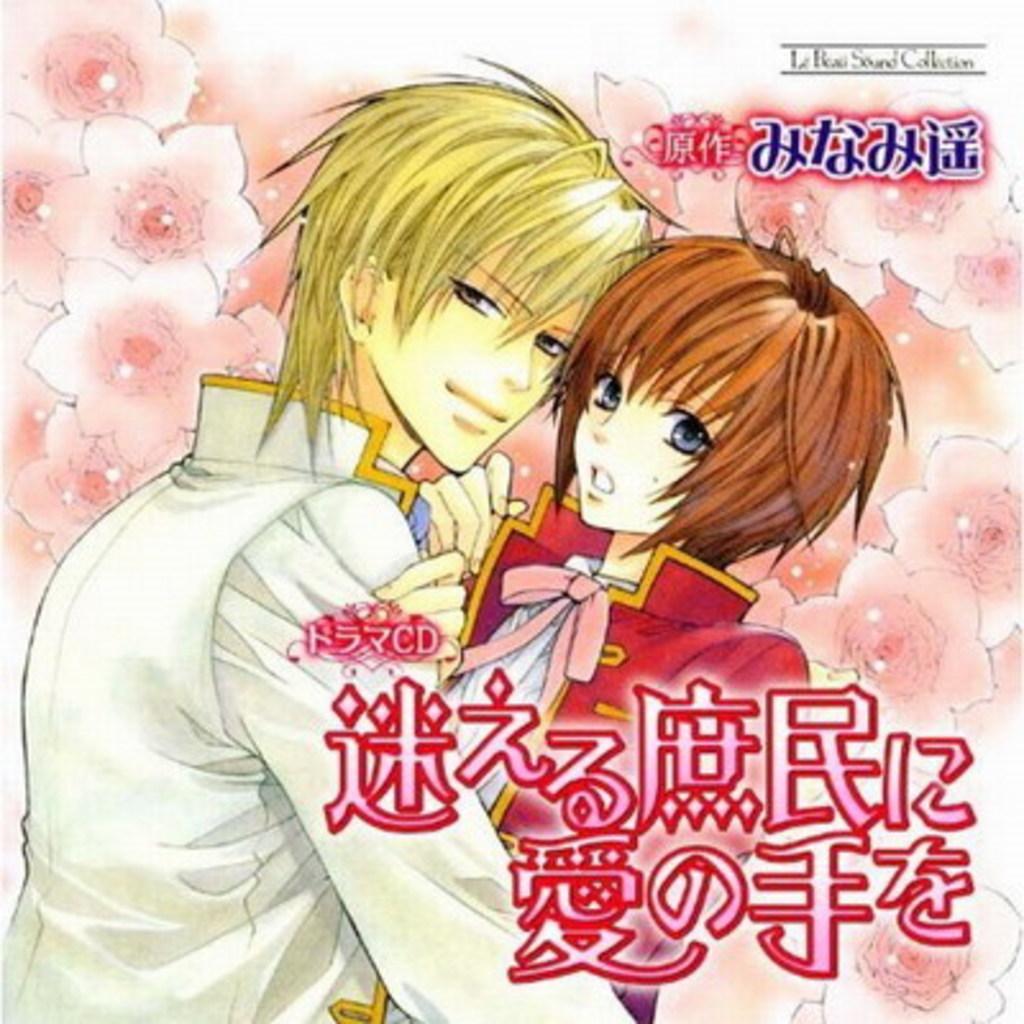Can you describe this image briefly? This is an edited image. We can see cartoon images of a boy, girl, flowers and texts written on the image. 